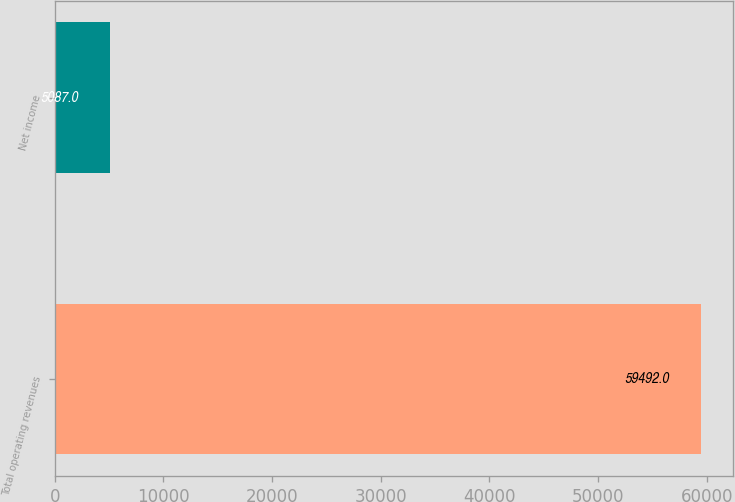Convert chart. <chart><loc_0><loc_0><loc_500><loc_500><bar_chart><fcel>Total operating revenues<fcel>Net income<nl><fcel>59492<fcel>5087<nl></chart> 